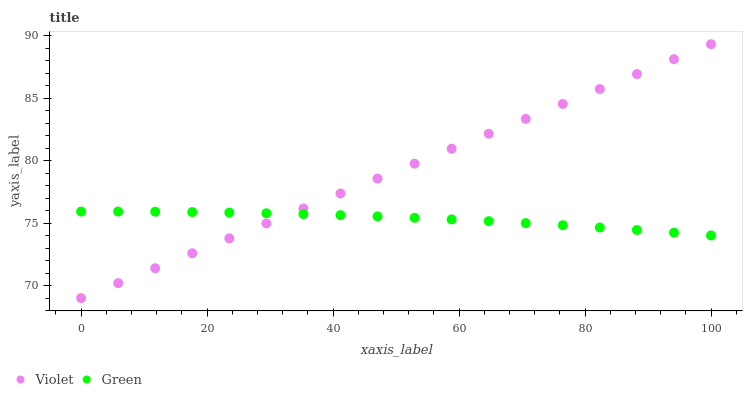Does Green have the minimum area under the curve?
Answer yes or no. Yes. Does Violet have the maximum area under the curve?
Answer yes or no. Yes. Does Violet have the minimum area under the curve?
Answer yes or no. No. Is Violet the smoothest?
Answer yes or no. Yes. Is Green the roughest?
Answer yes or no. Yes. Is Violet the roughest?
Answer yes or no. No. Does Violet have the lowest value?
Answer yes or no. Yes. Does Violet have the highest value?
Answer yes or no. Yes. Does Green intersect Violet?
Answer yes or no. Yes. Is Green less than Violet?
Answer yes or no. No. Is Green greater than Violet?
Answer yes or no. No. 